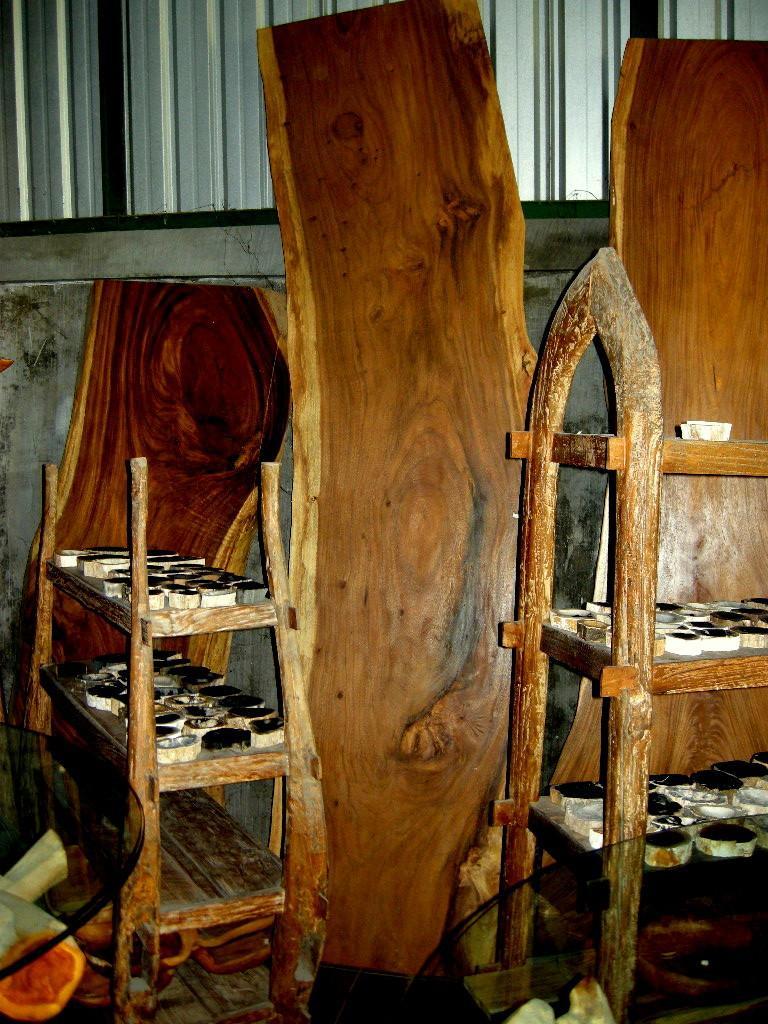In one or two sentences, can you explain what this image depicts? This picture might be taken inside the room. In this image, on the right side, we can see a shelf, on the shelf, we can see some cups. On the right side corner, we can also see the edge of the table. On the left side, we can also see another edge of the table. On the left side, we can see a shelf, on the shelf, we can see some cups. In the middle of the image, we can see a wood plank. In the background, we can see a window which is closed. 